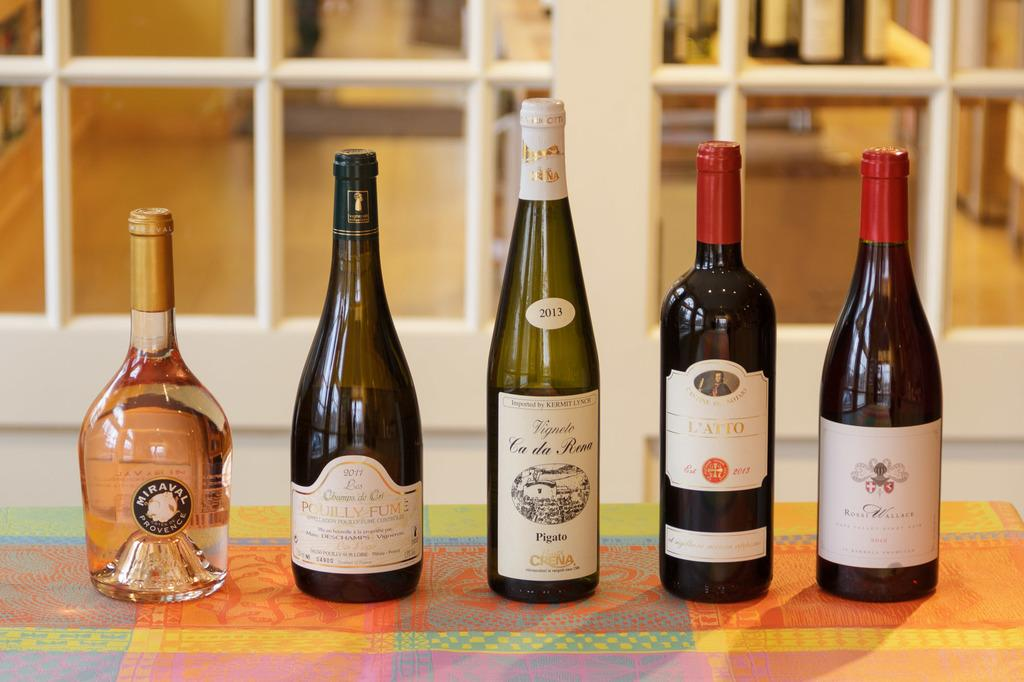What objects are arranged in a row in the image? There are bottles arranged in a row in the image. Where are the bottles located? The bottles are placed on the floor. What can be seen in the background of the image? There is a window in the background of the image. How many breaths does the tooth take in a week in the image? There is no tooth present in the image, so it is not possible to determine how many breaths it might take in a week. 